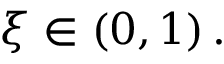Convert formula to latex. <formula><loc_0><loc_0><loc_500><loc_500>\xi \in \left ( 0 , 1 \right ) .</formula> 